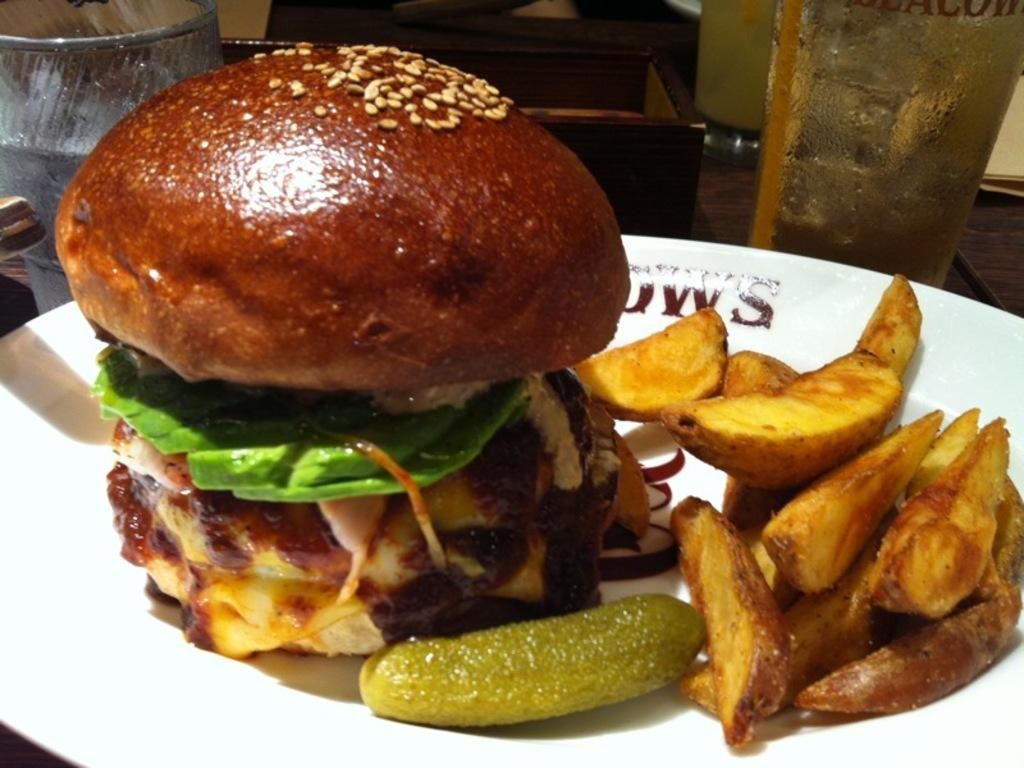What type of food is on the plate in the image? There is a burger on a plate in the image. What other food item is on the plate with the burger? There are potato wedges on the plate in the image. What beverage is visible in the image? There is a glass of water beside the plate in the image. What type of horn can be seen on the burger in the image? There is no horn present on the burger in the image. What arithmetic problem is solved on the plate in the image? There is no arithmetic problem present on the plate in the image. 